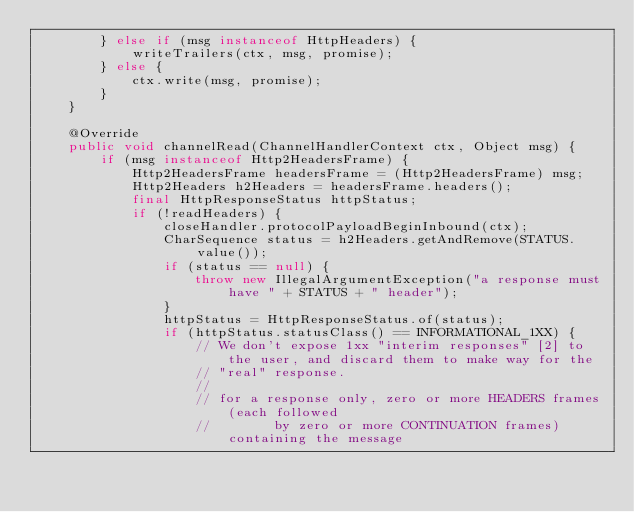Convert code to text. <code><loc_0><loc_0><loc_500><loc_500><_Java_>        } else if (msg instanceof HttpHeaders) {
            writeTrailers(ctx, msg, promise);
        } else {
            ctx.write(msg, promise);
        }
    }

    @Override
    public void channelRead(ChannelHandlerContext ctx, Object msg) {
        if (msg instanceof Http2HeadersFrame) {
            Http2HeadersFrame headersFrame = (Http2HeadersFrame) msg;
            Http2Headers h2Headers = headersFrame.headers();
            final HttpResponseStatus httpStatus;
            if (!readHeaders) {
                closeHandler.protocolPayloadBeginInbound(ctx);
                CharSequence status = h2Headers.getAndRemove(STATUS.value());
                if (status == null) {
                    throw new IllegalArgumentException("a response must have " + STATUS + " header");
                }
                httpStatus = HttpResponseStatus.of(status);
                if (httpStatus.statusClass() == INFORMATIONAL_1XX) {
                    // We don't expose 1xx "interim responses" [2] to the user, and discard them to make way for the
                    // "real" response.
                    //
                    // for a response only, zero or more HEADERS frames (each followed
                    //        by zero or more CONTINUATION frames) containing the message</code> 